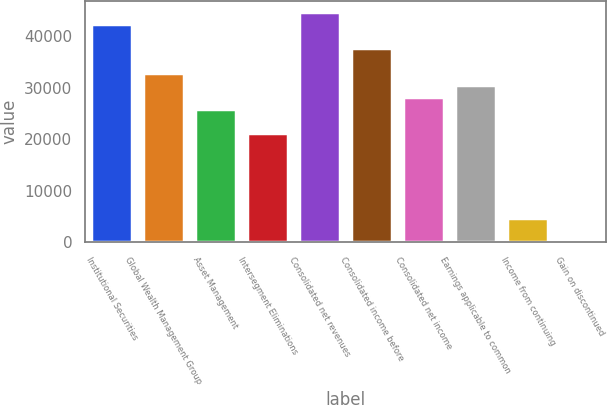<chart> <loc_0><loc_0><loc_500><loc_500><bar_chart><fcel>Institutional Securities<fcel>Global Wealth Management Group<fcel>Asset Management<fcel>Intersegment Eliminations<fcel>Consolidated net revenues<fcel>Consolidated income before<fcel>Consolidated net income<fcel>Earnings applicable to common<fcel>Income from continuing<fcel>Gain on discontinued<nl><fcel>42344.8<fcel>32934.9<fcel>25877.5<fcel>21172.6<fcel>44697.3<fcel>37639.8<fcel>28230<fcel>30582.4<fcel>4705.27<fcel>0.33<nl></chart> 